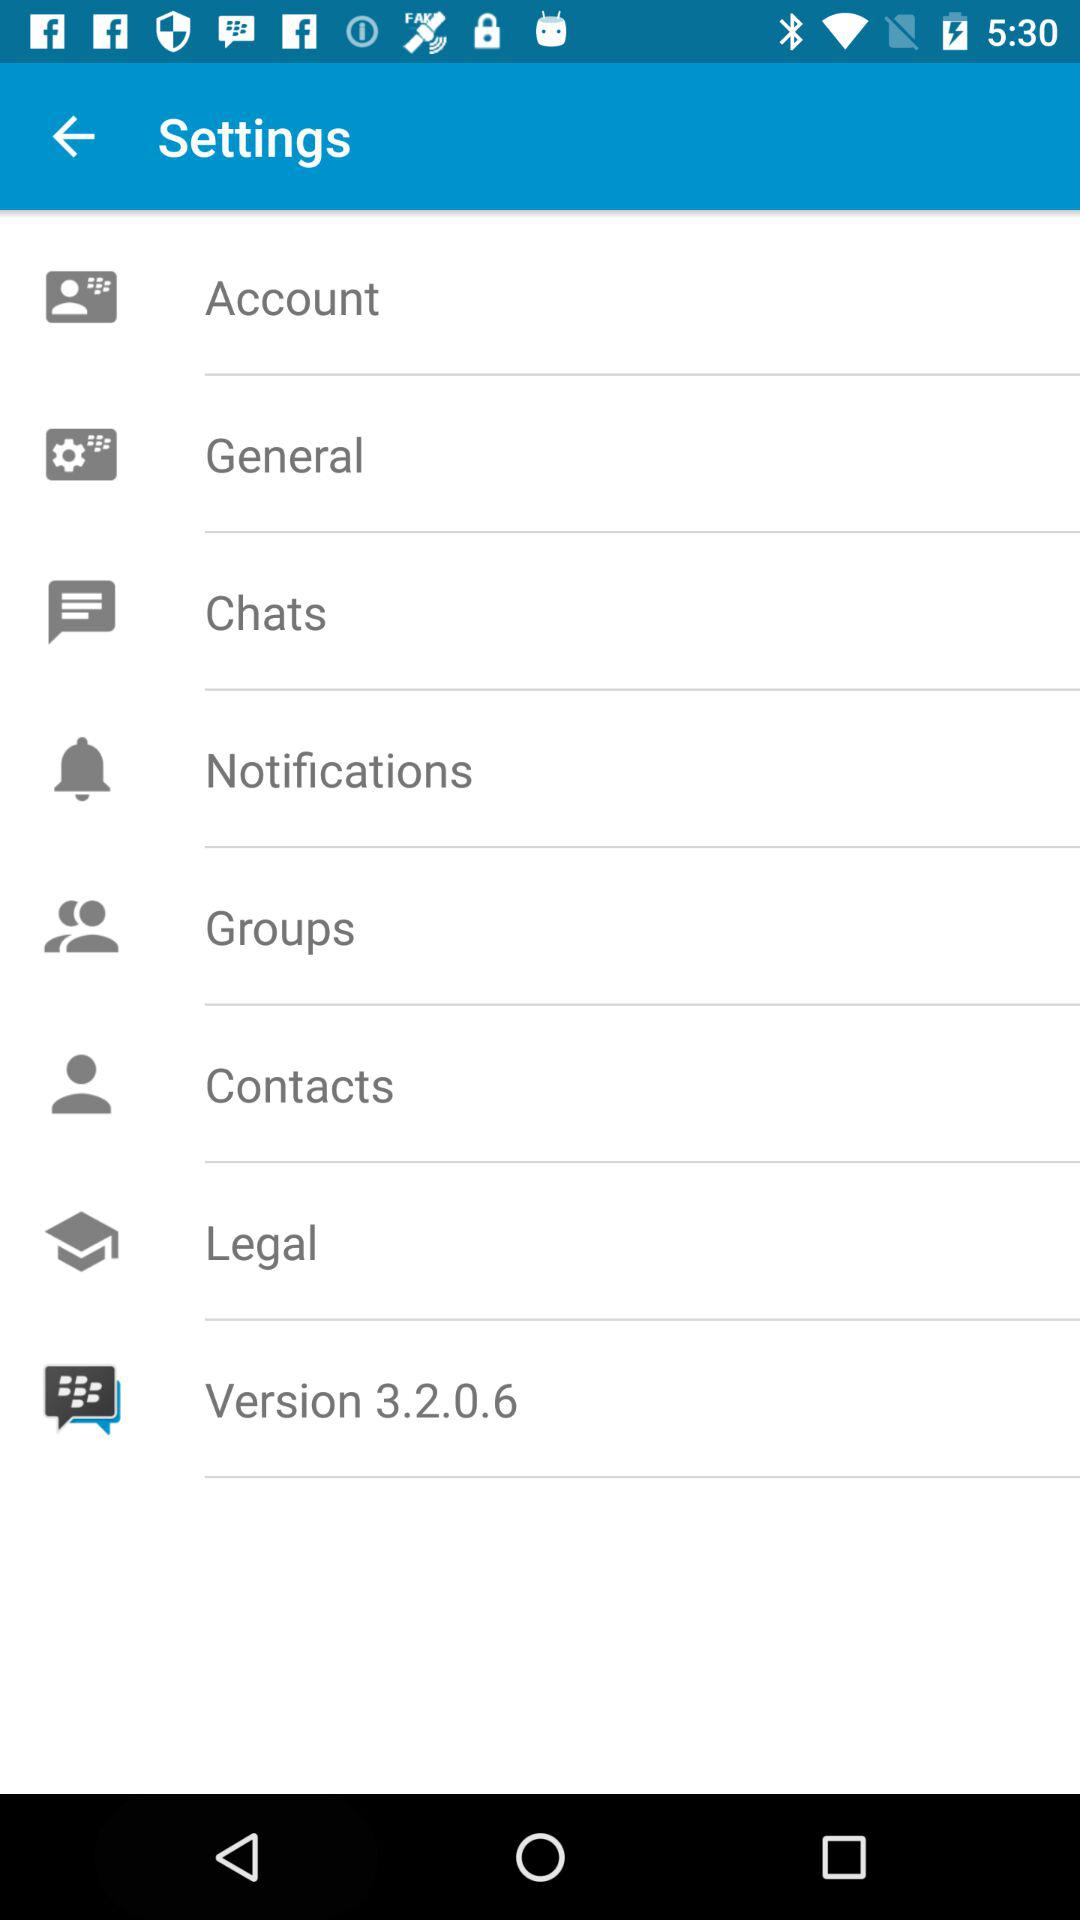What is the version? The version is 3.2.0.6. 